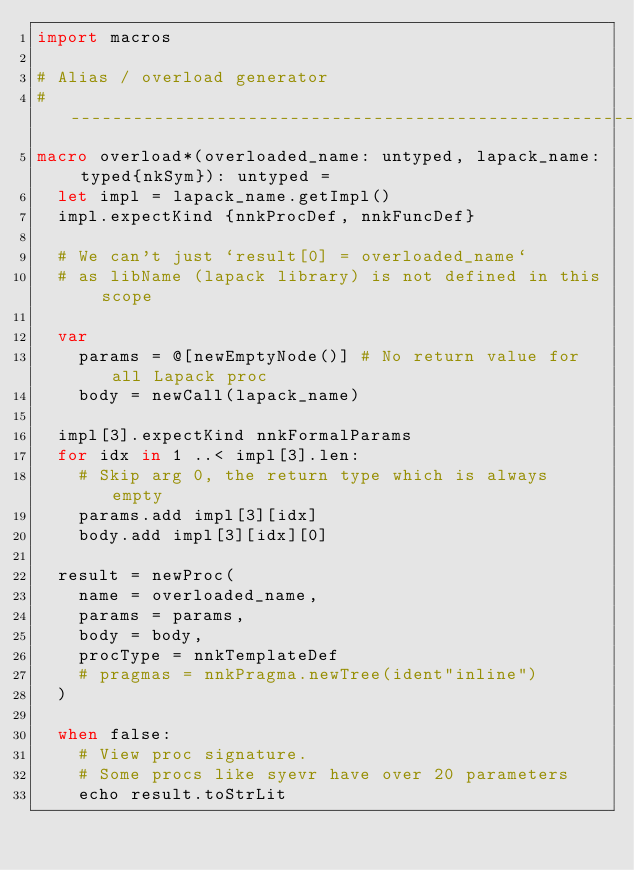Convert code to text. <code><loc_0><loc_0><loc_500><loc_500><_Nim_>import macros

# Alias / overload generator
# --------------------------------------------------------------------------------------
macro overload*(overloaded_name: untyped, lapack_name: typed{nkSym}): untyped =
  let impl = lapack_name.getImpl()
  impl.expectKind {nnkProcDef, nnkFuncDef}

  # We can't just `result[0] = overloaded_name`
  # as libName (lapack library) is not defined in this scope

  var
    params = @[newEmptyNode()] # No return value for all Lapack proc
    body = newCall(lapack_name)

  impl[3].expectKind nnkFormalParams
  for idx in 1 ..< impl[3].len:
    # Skip arg 0, the return type which is always empty
    params.add impl[3][idx]
    body.add impl[3][idx][0]

  result = newProc(
    name = overloaded_name,
    params = params,
    body = body,
    procType = nnkTemplateDef
    # pragmas = nnkPragma.newTree(ident"inline")
  )

  when false:
    # View proc signature.
    # Some procs like syevr have over 20 parameters
    echo result.toStrLit
</code> 